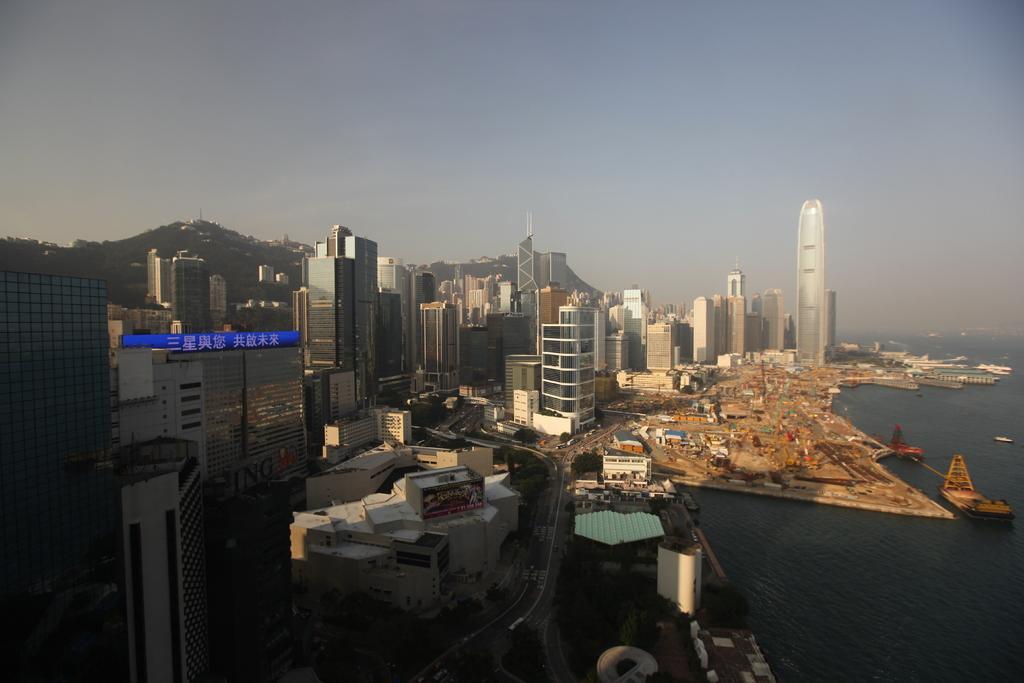How would you summarize this image in a sentence or two? In this image we can see buildings, harbor, ships, water, hills, road, vehicles, sky and clouds. 